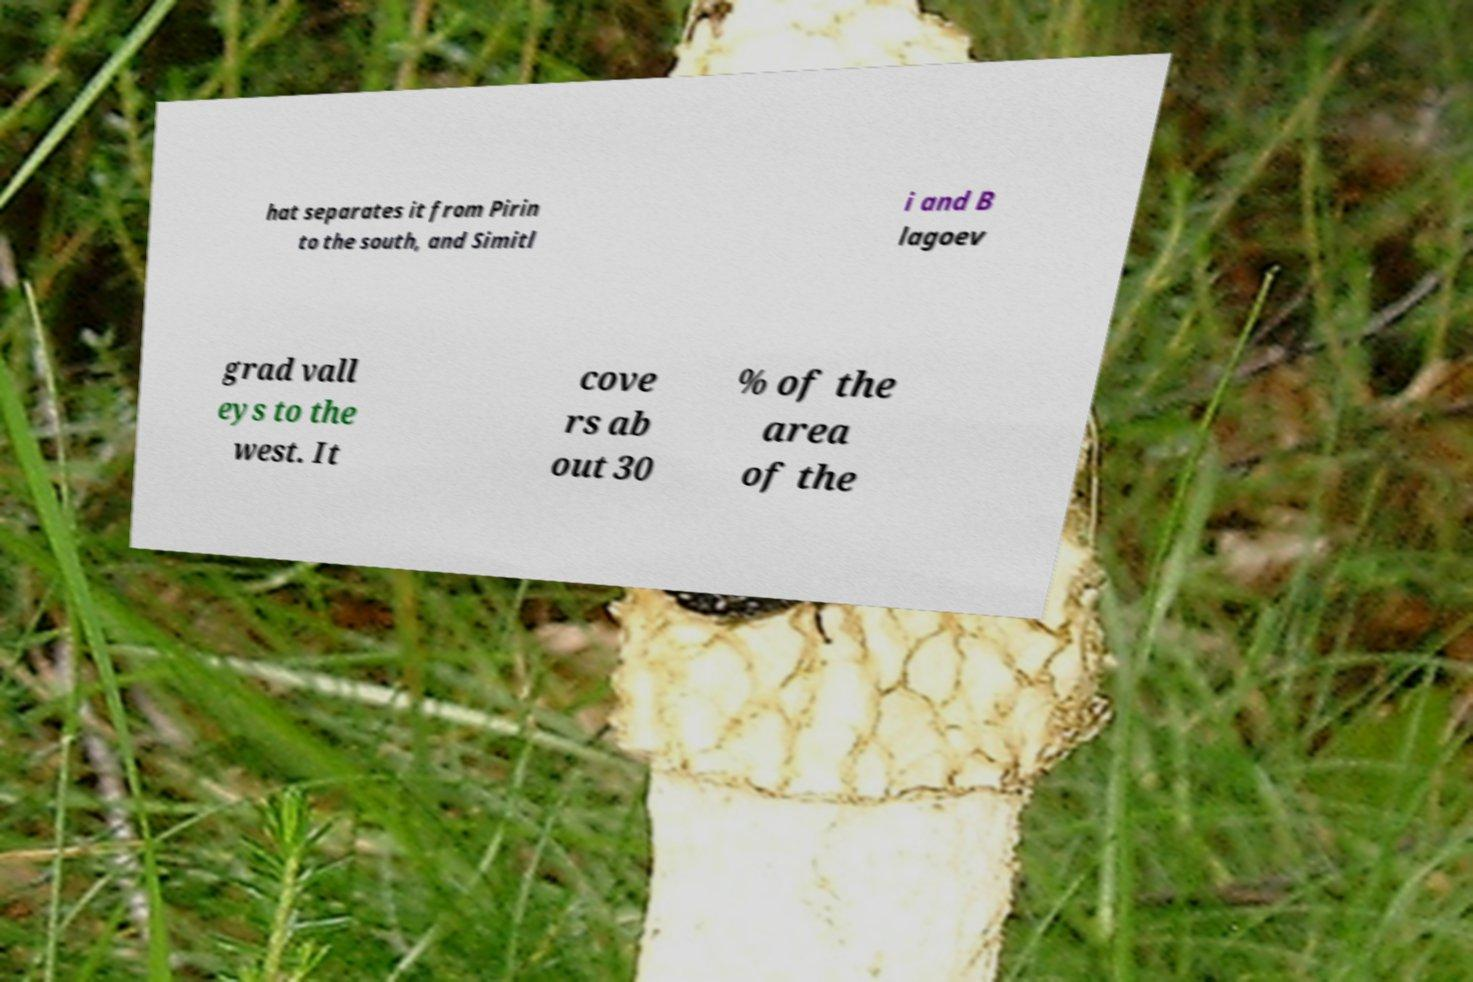Could you extract and type out the text from this image? hat separates it from Pirin to the south, and Simitl i and B lagoev grad vall eys to the west. It cove rs ab out 30 % of the area of the 